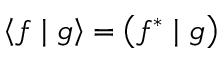<formula> <loc_0><loc_0><loc_500><loc_500>\left \langle f | g \right \rangle = \left ( f ^ { * } | g \right )</formula> 